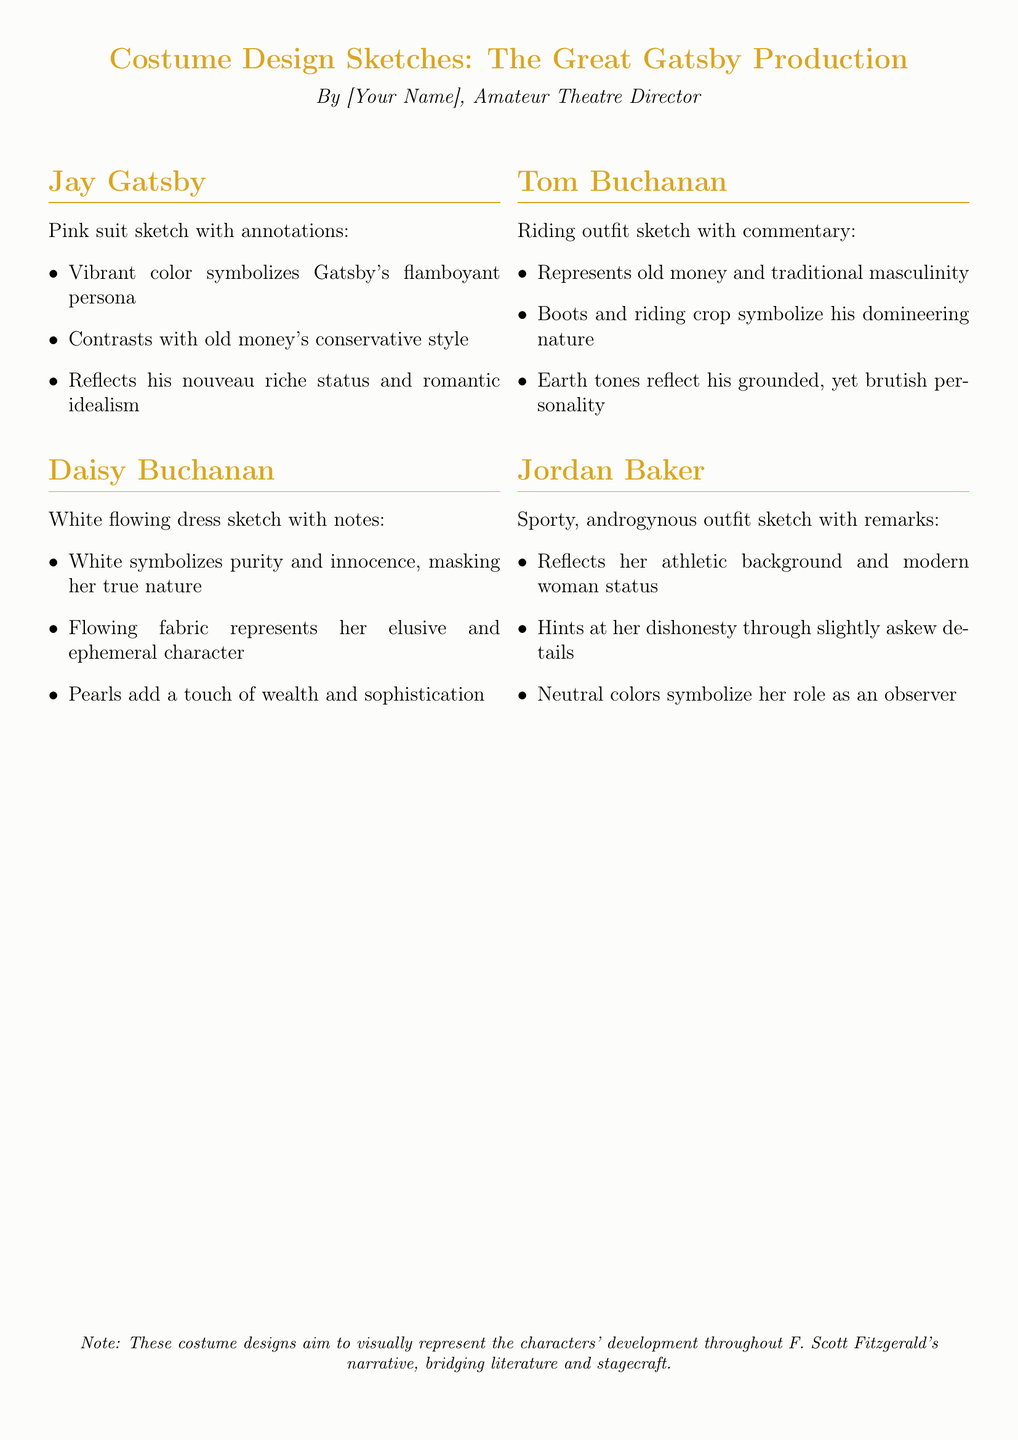What color is Jay Gatsby's suit? The document describes Gatsby's suit as pink, which is an important detail for character symbolism.
Answer: Pink What does Daisy's white dress symbolize? The document states that white symbolizes purity and innocence, which is critical to understanding her character.
Answer: Purity and innocence Which character's outfit represents old money? The sketch for Tom Buchanan's riding outfit is representative of old money and traditional masculinity.
Answer: Tom Buchanan What do the pearls in Daisy's outfit represent? The document notes that pearls add a touch of wealth and sophistication to Daisy's character, highlighting her social status.
Answer: Wealth and sophistication What color tones are used in Tom Buchanan's riding outfit? The sketches indicate that earth tones are used for Tom Buchanan's outfit, reflecting his grounded personality.
Answer: Earth tones What type of outfit does Jordan Baker wear? The document describes Jordan Baker's outfit as sporty and androgynous, showcasing her modernity.
Answer: Sporty androgynous What does Gatsby's vibrant suit contrast with? The vibrant color of Gatsby's suit contrasts with the conservative style of old money, emphasizing his status.
Answer: Old money's conservative style How do the costume designs contribute to character development? The designs aim to visually represent the characters' development throughout the narrative of The Great Gatsby.
Answer: Visually represent character development What does the flowing fabric of Daisy's dress represent? The flowing fabric of Daisy's dress represents her elusive and ephemeral character, which is an important aspect of her role.
Answer: Elusive and ephemeral character 